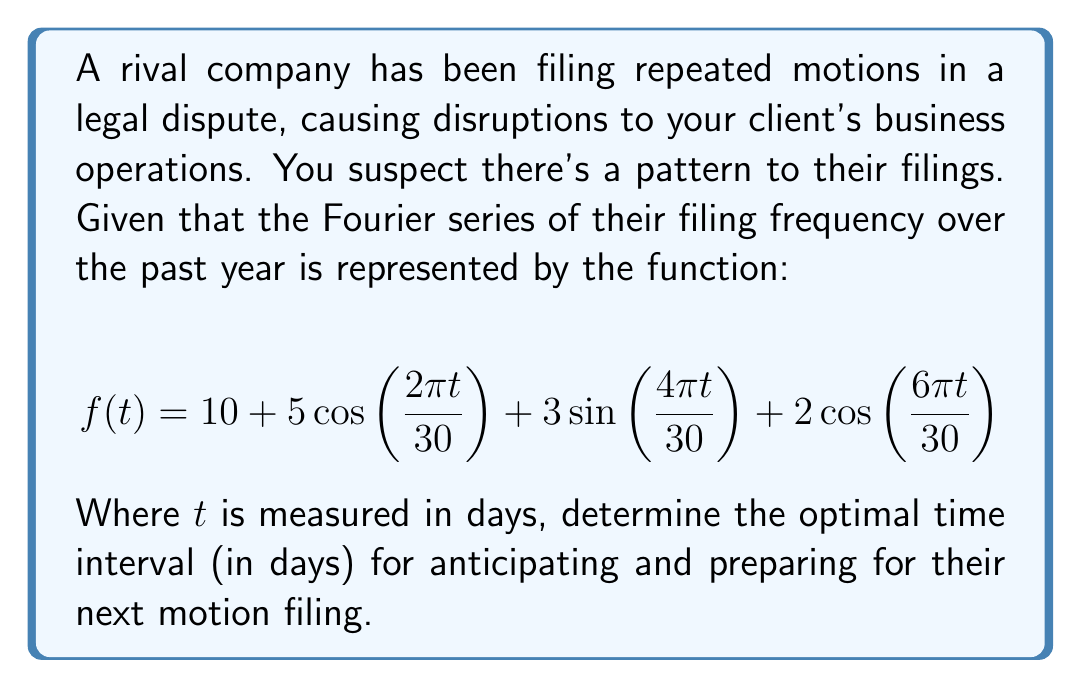Can you answer this question? To solve this problem, we need to analyze the Fourier series representation of the filing frequency:

1) The given Fourier series is:
   $$f(t) = 10 + 5\cos(\frac{2\pi t}{30}) + 3\sin(\frac{4\pi t}{30}) + 2\cos(\frac{6\pi t}{30})$$

2) The constant term 10 represents the average filing frequency.

3) The periodic components are:
   - $5\cos(\frac{2\pi t}{30})$ with period $T_1 = 30$ days
   - $3\sin(\frac{4\pi t}{30})$ with period $T_2 = 15$ days
   - $2\cos(\frac{6\pi t}{30})$ with period $T_3 = 10$ days

4) To find the overall period of the function, we need to find the least common multiple (LCM) of these individual periods:
   
   $LCM(30, 15, 10) = 30$

5) This means the pattern repeats every 30 days.

6) However, for optimal preparation, we should anticipate filings at half this interval, which is 15 days. This allows us to be prepared for both the peaks and troughs of the filing frequency.

Therefore, the optimal time interval for anticipating and preparing for their next motion filing is 15 days.
Answer: 15 days 